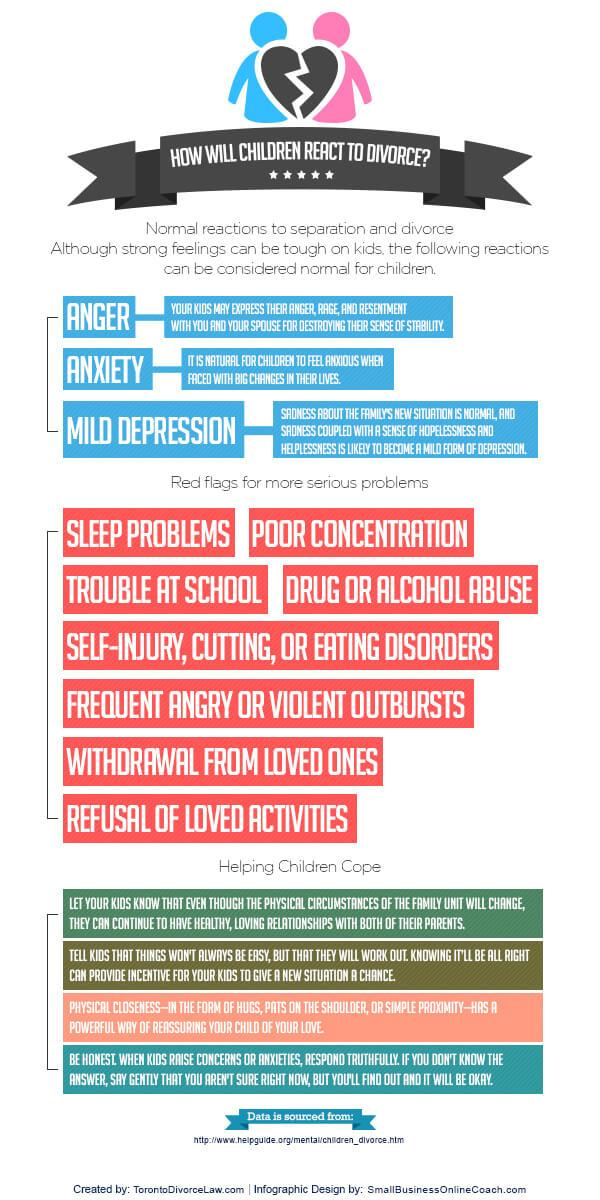Outline some significant characteristics in this image. Typically, children facing divorce may experience a range of emotions including anger, anxiety, and mild depression. The infographic lists 3 normal reactions that children facing divorce may experience. Poor concentration is the second most serious problem faced by children when their parents divorce. Based on the information given, it can be declared that the color of the flag given to children facing divorce is blue. Drug or alcohol abuse is the fourth serious problem that children often face when their parents divorce. 